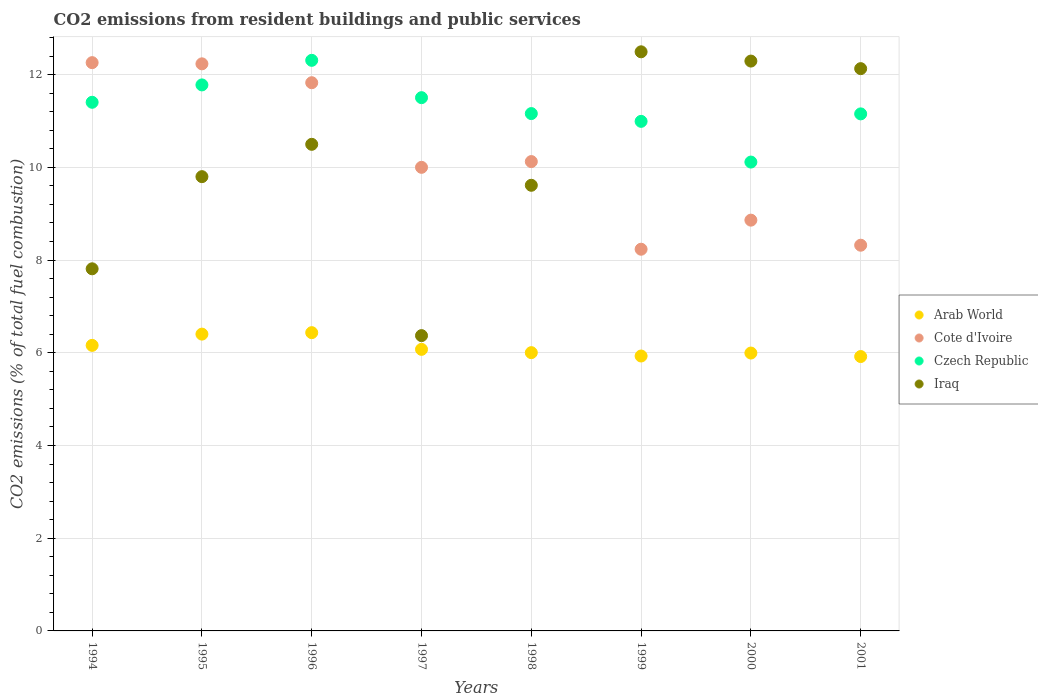Is the number of dotlines equal to the number of legend labels?
Give a very brief answer. Yes. What is the total CO2 emitted in Iraq in 1994?
Offer a very short reply. 7.81. Across all years, what is the maximum total CO2 emitted in Cote d'Ivoire?
Your answer should be very brief. 12.26. Across all years, what is the minimum total CO2 emitted in Iraq?
Your response must be concise. 6.37. In which year was the total CO2 emitted in Arab World maximum?
Ensure brevity in your answer.  1996. In which year was the total CO2 emitted in Iraq minimum?
Your response must be concise. 1997. What is the total total CO2 emitted in Iraq in the graph?
Provide a short and direct response. 81. What is the difference between the total CO2 emitted in Czech Republic in 1995 and that in 2001?
Your answer should be very brief. 0.62. What is the difference between the total CO2 emitted in Czech Republic in 1998 and the total CO2 emitted in Cote d'Ivoire in 1999?
Give a very brief answer. 2.93. What is the average total CO2 emitted in Iraq per year?
Ensure brevity in your answer.  10.13. In the year 1994, what is the difference between the total CO2 emitted in Arab World and total CO2 emitted in Iraq?
Offer a very short reply. -1.65. In how many years, is the total CO2 emitted in Cote d'Ivoire greater than 10.8?
Keep it short and to the point. 3. What is the ratio of the total CO2 emitted in Czech Republic in 1994 to that in 1996?
Offer a very short reply. 0.93. Is the total CO2 emitted in Arab World in 1996 less than that in 1997?
Offer a terse response. No. What is the difference between the highest and the second highest total CO2 emitted in Iraq?
Offer a very short reply. 0.2. What is the difference between the highest and the lowest total CO2 emitted in Czech Republic?
Give a very brief answer. 2.19. Is the sum of the total CO2 emitted in Cote d'Ivoire in 1996 and 2001 greater than the maximum total CO2 emitted in Czech Republic across all years?
Offer a very short reply. Yes. Is it the case that in every year, the sum of the total CO2 emitted in Cote d'Ivoire and total CO2 emitted in Iraq  is greater than the sum of total CO2 emitted in Arab World and total CO2 emitted in Czech Republic?
Offer a terse response. No. Is it the case that in every year, the sum of the total CO2 emitted in Arab World and total CO2 emitted in Iraq  is greater than the total CO2 emitted in Czech Republic?
Your answer should be very brief. Yes. How many dotlines are there?
Offer a terse response. 4. How many years are there in the graph?
Keep it short and to the point. 8. What is the difference between two consecutive major ticks on the Y-axis?
Your response must be concise. 2. Does the graph contain grids?
Your response must be concise. Yes. How many legend labels are there?
Make the answer very short. 4. What is the title of the graph?
Provide a short and direct response. CO2 emissions from resident buildings and public services. What is the label or title of the Y-axis?
Make the answer very short. CO2 emissions (% of total fuel combustion). What is the CO2 emissions (% of total fuel combustion) in Arab World in 1994?
Your answer should be compact. 6.16. What is the CO2 emissions (% of total fuel combustion) of Cote d'Ivoire in 1994?
Make the answer very short. 12.26. What is the CO2 emissions (% of total fuel combustion) in Czech Republic in 1994?
Ensure brevity in your answer.  11.4. What is the CO2 emissions (% of total fuel combustion) in Iraq in 1994?
Make the answer very short. 7.81. What is the CO2 emissions (% of total fuel combustion) of Arab World in 1995?
Offer a terse response. 6.4. What is the CO2 emissions (% of total fuel combustion) of Cote d'Ivoire in 1995?
Your answer should be compact. 12.23. What is the CO2 emissions (% of total fuel combustion) of Czech Republic in 1995?
Make the answer very short. 11.78. What is the CO2 emissions (% of total fuel combustion) of Iraq in 1995?
Offer a terse response. 9.8. What is the CO2 emissions (% of total fuel combustion) of Arab World in 1996?
Offer a very short reply. 6.43. What is the CO2 emissions (% of total fuel combustion) in Cote d'Ivoire in 1996?
Offer a terse response. 11.83. What is the CO2 emissions (% of total fuel combustion) in Czech Republic in 1996?
Provide a succinct answer. 12.31. What is the CO2 emissions (% of total fuel combustion) of Iraq in 1996?
Ensure brevity in your answer.  10.5. What is the CO2 emissions (% of total fuel combustion) of Arab World in 1997?
Ensure brevity in your answer.  6.07. What is the CO2 emissions (% of total fuel combustion) in Czech Republic in 1997?
Your answer should be compact. 11.5. What is the CO2 emissions (% of total fuel combustion) in Iraq in 1997?
Give a very brief answer. 6.37. What is the CO2 emissions (% of total fuel combustion) of Arab World in 1998?
Your answer should be compact. 6. What is the CO2 emissions (% of total fuel combustion) of Cote d'Ivoire in 1998?
Ensure brevity in your answer.  10.12. What is the CO2 emissions (% of total fuel combustion) of Czech Republic in 1998?
Keep it short and to the point. 11.16. What is the CO2 emissions (% of total fuel combustion) in Iraq in 1998?
Offer a very short reply. 9.61. What is the CO2 emissions (% of total fuel combustion) in Arab World in 1999?
Your answer should be compact. 5.93. What is the CO2 emissions (% of total fuel combustion) of Cote d'Ivoire in 1999?
Your answer should be compact. 8.23. What is the CO2 emissions (% of total fuel combustion) in Czech Republic in 1999?
Offer a terse response. 10.99. What is the CO2 emissions (% of total fuel combustion) in Iraq in 1999?
Keep it short and to the point. 12.49. What is the CO2 emissions (% of total fuel combustion) in Arab World in 2000?
Provide a succinct answer. 5.99. What is the CO2 emissions (% of total fuel combustion) in Cote d'Ivoire in 2000?
Provide a succinct answer. 8.86. What is the CO2 emissions (% of total fuel combustion) of Czech Republic in 2000?
Your answer should be compact. 10.11. What is the CO2 emissions (% of total fuel combustion) of Iraq in 2000?
Keep it short and to the point. 12.29. What is the CO2 emissions (% of total fuel combustion) of Arab World in 2001?
Offer a terse response. 5.92. What is the CO2 emissions (% of total fuel combustion) of Cote d'Ivoire in 2001?
Your response must be concise. 8.32. What is the CO2 emissions (% of total fuel combustion) of Czech Republic in 2001?
Provide a short and direct response. 11.15. What is the CO2 emissions (% of total fuel combustion) in Iraq in 2001?
Your answer should be compact. 12.13. Across all years, what is the maximum CO2 emissions (% of total fuel combustion) in Arab World?
Offer a very short reply. 6.43. Across all years, what is the maximum CO2 emissions (% of total fuel combustion) in Cote d'Ivoire?
Your answer should be very brief. 12.26. Across all years, what is the maximum CO2 emissions (% of total fuel combustion) in Czech Republic?
Your answer should be very brief. 12.31. Across all years, what is the maximum CO2 emissions (% of total fuel combustion) of Iraq?
Your response must be concise. 12.49. Across all years, what is the minimum CO2 emissions (% of total fuel combustion) in Arab World?
Provide a short and direct response. 5.92. Across all years, what is the minimum CO2 emissions (% of total fuel combustion) of Cote d'Ivoire?
Make the answer very short. 8.23. Across all years, what is the minimum CO2 emissions (% of total fuel combustion) in Czech Republic?
Ensure brevity in your answer.  10.11. Across all years, what is the minimum CO2 emissions (% of total fuel combustion) of Iraq?
Provide a succinct answer. 6.37. What is the total CO2 emissions (% of total fuel combustion) of Arab World in the graph?
Your answer should be very brief. 48.91. What is the total CO2 emissions (% of total fuel combustion) in Cote d'Ivoire in the graph?
Ensure brevity in your answer.  81.85. What is the total CO2 emissions (% of total fuel combustion) of Czech Republic in the graph?
Provide a succinct answer. 90.41. What is the total CO2 emissions (% of total fuel combustion) in Iraq in the graph?
Provide a short and direct response. 81. What is the difference between the CO2 emissions (% of total fuel combustion) in Arab World in 1994 and that in 1995?
Your response must be concise. -0.24. What is the difference between the CO2 emissions (% of total fuel combustion) in Cote d'Ivoire in 1994 and that in 1995?
Offer a terse response. 0.03. What is the difference between the CO2 emissions (% of total fuel combustion) in Czech Republic in 1994 and that in 1995?
Your answer should be compact. -0.37. What is the difference between the CO2 emissions (% of total fuel combustion) in Iraq in 1994 and that in 1995?
Provide a succinct answer. -1.99. What is the difference between the CO2 emissions (% of total fuel combustion) in Arab World in 1994 and that in 1996?
Provide a succinct answer. -0.27. What is the difference between the CO2 emissions (% of total fuel combustion) of Cote d'Ivoire in 1994 and that in 1996?
Your response must be concise. 0.43. What is the difference between the CO2 emissions (% of total fuel combustion) in Czech Republic in 1994 and that in 1996?
Offer a very short reply. -0.9. What is the difference between the CO2 emissions (% of total fuel combustion) in Iraq in 1994 and that in 1996?
Ensure brevity in your answer.  -2.69. What is the difference between the CO2 emissions (% of total fuel combustion) in Arab World in 1994 and that in 1997?
Your answer should be very brief. 0.09. What is the difference between the CO2 emissions (% of total fuel combustion) in Cote d'Ivoire in 1994 and that in 1997?
Provide a succinct answer. 2.26. What is the difference between the CO2 emissions (% of total fuel combustion) of Czech Republic in 1994 and that in 1997?
Ensure brevity in your answer.  -0.1. What is the difference between the CO2 emissions (% of total fuel combustion) in Iraq in 1994 and that in 1997?
Provide a succinct answer. 1.44. What is the difference between the CO2 emissions (% of total fuel combustion) of Arab World in 1994 and that in 1998?
Your response must be concise. 0.16. What is the difference between the CO2 emissions (% of total fuel combustion) in Cote d'Ivoire in 1994 and that in 1998?
Offer a terse response. 2.13. What is the difference between the CO2 emissions (% of total fuel combustion) in Czech Republic in 1994 and that in 1998?
Your answer should be compact. 0.24. What is the difference between the CO2 emissions (% of total fuel combustion) of Iraq in 1994 and that in 1998?
Make the answer very short. -1.8. What is the difference between the CO2 emissions (% of total fuel combustion) of Arab World in 1994 and that in 1999?
Offer a very short reply. 0.23. What is the difference between the CO2 emissions (% of total fuel combustion) of Cote d'Ivoire in 1994 and that in 1999?
Offer a terse response. 4.02. What is the difference between the CO2 emissions (% of total fuel combustion) in Czech Republic in 1994 and that in 1999?
Keep it short and to the point. 0.41. What is the difference between the CO2 emissions (% of total fuel combustion) in Iraq in 1994 and that in 1999?
Your answer should be very brief. -4.68. What is the difference between the CO2 emissions (% of total fuel combustion) in Arab World in 1994 and that in 2000?
Keep it short and to the point. 0.17. What is the difference between the CO2 emissions (% of total fuel combustion) in Cote d'Ivoire in 1994 and that in 2000?
Your answer should be very brief. 3.4. What is the difference between the CO2 emissions (% of total fuel combustion) of Czech Republic in 1994 and that in 2000?
Keep it short and to the point. 1.29. What is the difference between the CO2 emissions (% of total fuel combustion) in Iraq in 1994 and that in 2000?
Make the answer very short. -4.48. What is the difference between the CO2 emissions (% of total fuel combustion) in Arab World in 1994 and that in 2001?
Provide a short and direct response. 0.24. What is the difference between the CO2 emissions (% of total fuel combustion) in Cote d'Ivoire in 1994 and that in 2001?
Ensure brevity in your answer.  3.94. What is the difference between the CO2 emissions (% of total fuel combustion) of Czech Republic in 1994 and that in 2001?
Your answer should be compact. 0.25. What is the difference between the CO2 emissions (% of total fuel combustion) in Iraq in 1994 and that in 2001?
Your answer should be compact. -4.32. What is the difference between the CO2 emissions (% of total fuel combustion) in Arab World in 1995 and that in 1996?
Provide a succinct answer. -0.03. What is the difference between the CO2 emissions (% of total fuel combustion) in Cote d'Ivoire in 1995 and that in 1996?
Your response must be concise. 0.41. What is the difference between the CO2 emissions (% of total fuel combustion) in Czech Republic in 1995 and that in 1996?
Keep it short and to the point. -0.53. What is the difference between the CO2 emissions (% of total fuel combustion) of Iraq in 1995 and that in 1996?
Make the answer very short. -0.7. What is the difference between the CO2 emissions (% of total fuel combustion) in Arab World in 1995 and that in 1997?
Your response must be concise. 0.33. What is the difference between the CO2 emissions (% of total fuel combustion) of Cote d'Ivoire in 1995 and that in 1997?
Your answer should be compact. 2.23. What is the difference between the CO2 emissions (% of total fuel combustion) of Czech Republic in 1995 and that in 1997?
Make the answer very short. 0.28. What is the difference between the CO2 emissions (% of total fuel combustion) in Iraq in 1995 and that in 1997?
Your response must be concise. 3.43. What is the difference between the CO2 emissions (% of total fuel combustion) of Arab World in 1995 and that in 1998?
Offer a terse response. 0.4. What is the difference between the CO2 emissions (% of total fuel combustion) of Cote d'Ivoire in 1995 and that in 1998?
Give a very brief answer. 2.11. What is the difference between the CO2 emissions (% of total fuel combustion) in Czech Republic in 1995 and that in 1998?
Keep it short and to the point. 0.62. What is the difference between the CO2 emissions (% of total fuel combustion) of Iraq in 1995 and that in 1998?
Keep it short and to the point. 0.19. What is the difference between the CO2 emissions (% of total fuel combustion) in Arab World in 1995 and that in 1999?
Make the answer very short. 0.47. What is the difference between the CO2 emissions (% of total fuel combustion) of Cote d'Ivoire in 1995 and that in 1999?
Ensure brevity in your answer.  4. What is the difference between the CO2 emissions (% of total fuel combustion) of Czech Republic in 1995 and that in 1999?
Offer a very short reply. 0.79. What is the difference between the CO2 emissions (% of total fuel combustion) of Iraq in 1995 and that in 1999?
Make the answer very short. -2.69. What is the difference between the CO2 emissions (% of total fuel combustion) in Arab World in 1995 and that in 2000?
Make the answer very short. 0.41. What is the difference between the CO2 emissions (% of total fuel combustion) of Cote d'Ivoire in 1995 and that in 2000?
Give a very brief answer. 3.37. What is the difference between the CO2 emissions (% of total fuel combustion) in Czech Republic in 1995 and that in 2000?
Provide a short and direct response. 1.66. What is the difference between the CO2 emissions (% of total fuel combustion) of Iraq in 1995 and that in 2000?
Provide a short and direct response. -2.49. What is the difference between the CO2 emissions (% of total fuel combustion) of Arab World in 1995 and that in 2001?
Your answer should be compact. 0.48. What is the difference between the CO2 emissions (% of total fuel combustion) in Cote d'Ivoire in 1995 and that in 2001?
Your answer should be very brief. 3.91. What is the difference between the CO2 emissions (% of total fuel combustion) of Czech Republic in 1995 and that in 2001?
Ensure brevity in your answer.  0.62. What is the difference between the CO2 emissions (% of total fuel combustion) in Iraq in 1995 and that in 2001?
Offer a very short reply. -2.33. What is the difference between the CO2 emissions (% of total fuel combustion) in Arab World in 1996 and that in 1997?
Keep it short and to the point. 0.36. What is the difference between the CO2 emissions (% of total fuel combustion) in Cote d'Ivoire in 1996 and that in 1997?
Provide a succinct answer. 1.83. What is the difference between the CO2 emissions (% of total fuel combustion) of Czech Republic in 1996 and that in 1997?
Provide a succinct answer. 0.81. What is the difference between the CO2 emissions (% of total fuel combustion) in Iraq in 1996 and that in 1997?
Your answer should be very brief. 4.13. What is the difference between the CO2 emissions (% of total fuel combustion) of Arab World in 1996 and that in 1998?
Your response must be concise. 0.43. What is the difference between the CO2 emissions (% of total fuel combustion) in Cote d'Ivoire in 1996 and that in 1998?
Offer a very short reply. 1.7. What is the difference between the CO2 emissions (% of total fuel combustion) in Czech Republic in 1996 and that in 1998?
Your response must be concise. 1.15. What is the difference between the CO2 emissions (% of total fuel combustion) in Iraq in 1996 and that in 1998?
Your response must be concise. 0.88. What is the difference between the CO2 emissions (% of total fuel combustion) in Arab World in 1996 and that in 1999?
Ensure brevity in your answer.  0.5. What is the difference between the CO2 emissions (% of total fuel combustion) of Cote d'Ivoire in 1996 and that in 1999?
Your answer should be very brief. 3.59. What is the difference between the CO2 emissions (% of total fuel combustion) in Czech Republic in 1996 and that in 1999?
Your response must be concise. 1.32. What is the difference between the CO2 emissions (% of total fuel combustion) of Iraq in 1996 and that in 1999?
Your answer should be very brief. -2. What is the difference between the CO2 emissions (% of total fuel combustion) in Arab World in 1996 and that in 2000?
Provide a short and direct response. 0.44. What is the difference between the CO2 emissions (% of total fuel combustion) of Cote d'Ivoire in 1996 and that in 2000?
Your answer should be compact. 2.96. What is the difference between the CO2 emissions (% of total fuel combustion) of Czech Republic in 1996 and that in 2000?
Ensure brevity in your answer.  2.19. What is the difference between the CO2 emissions (% of total fuel combustion) in Iraq in 1996 and that in 2000?
Make the answer very short. -1.8. What is the difference between the CO2 emissions (% of total fuel combustion) of Arab World in 1996 and that in 2001?
Your answer should be very brief. 0.52. What is the difference between the CO2 emissions (% of total fuel combustion) of Cote d'Ivoire in 1996 and that in 2001?
Ensure brevity in your answer.  3.51. What is the difference between the CO2 emissions (% of total fuel combustion) of Czech Republic in 1996 and that in 2001?
Ensure brevity in your answer.  1.16. What is the difference between the CO2 emissions (% of total fuel combustion) of Iraq in 1996 and that in 2001?
Provide a succinct answer. -1.63. What is the difference between the CO2 emissions (% of total fuel combustion) of Arab World in 1997 and that in 1998?
Your response must be concise. 0.07. What is the difference between the CO2 emissions (% of total fuel combustion) in Cote d'Ivoire in 1997 and that in 1998?
Offer a terse response. -0.12. What is the difference between the CO2 emissions (% of total fuel combustion) of Czech Republic in 1997 and that in 1998?
Offer a very short reply. 0.34. What is the difference between the CO2 emissions (% of total fuel combustion) in Iraq in 1997 and that in 1998?
Keep it short and to the point. -3.24. What is the difference between the CO2 emissions (% of total fuel combustion) of Arab World in 1997 and that in 1999?
Give a very brief answer. 0.14. What is the difference between the CO2 emissions (% of total fuel combustion) of Cote d'Ivoire in 1997 and that in 1999?
Give a very brief answer. 1.77. What is the difference between the CO2 emissions (% of total fuel combustion) in Czech Republic in 1997 and that in 1999?
Your answer should be very brief. 0.51. What is the difference between the CO2 emissions (% of total fuel combustion) of Iraq in 1997 and that in 1999?
Your answer should be very brief. -6.12. What is the difference between the CO2 emissions (% of total fuel combustion) in Arab World in 1997 and that in 2000?
Your answer should be very brief. 0.08. What is the difference between the CO2 emissions (% of total fuel combustion) of Cote d'Ivoire in 1997 and that in 2000?
Your answer should be compact. 1.14. What is the difference between the CO2 emissions (% of total fuel combustion) in Czech Republic in 1997 and that in 2000?
Keep it short and to the point. 1.39. What is the difference between the CO2 emissions (% of total fuel combustion) of Iraq in 1997 and that in 2000?
Provide a succinct answer. -5.92. What is the difference between the CO2 emissions (% of total fuel combustion) of Arab World in 1997 and that in 2001?
Your answer should be very brief. 0.15. What is the difference between the CO2 emissions (% of total fuel combustion) of Cote d'Ivoire in 1997 and that in 2001?
Give a very brief answer. 1.68. What is the difference between the CO2 emissions (% of total fuel combustion) in Czech Republic in 1997 and that in 2001?
Make the answer very short. 0.35. What is the difference between the CO2 emissions (% of total fuel combustion) of Iraq in 1997 and that in 2001?
Provide a short and direct response. -5.76. What is the difference between the CO2 emissions (% of total fuel combustion) in Arab World in 1998 and that in 1999?
Your answer should be very brief. 0.07. What is the difference between the CO2 emissions (% of total fuel combustion) of Cote d'Ivoire in 1998 and that in 1999?
Make the answer very short. 1.89. What is the difference between the CO2 emissions (% of total fuel combustion) in Czech Republic in 1998 and that in 1999?
Give a very brief answer. 0.17. What is the difference between the CO2 emissions (% of total fuel combustion) in Iraq in 1998 and that in 1999?
Provide a short and direct response. -2.88. What is the difference between the CO2 emissions (% of total fuel combustion) of Arab World in 1998 and that in 2000?
Make the answer very short. 0.01. What is the difference between the CO2 emissions (% of total fuel combustion) in Cote d'Ivoire in 1998 and that in 2000?
Your answer should be compact. 1.26. What is the difference between the CO2 emissions (% of total fuel combustion) in Czech Republic in 1998 and that in 2000?
Offer a very short reply. 1.05. What is the difference between the CO2 emissions (% of total fuel combustion) of Iraq in 1998 and that in 2000?
Your answer should be very brief. -2.68. What is the difference between the CO2 emissions (% of total fuel combustion) of Arab World in 1998 and that in 2001?
Provide a succinct answer. 0.08. What is the difference between the CO2 emissions (% of total fuel combustion) of Cote d'Ivoire in 1998 and that in 2001?
Your answer should be very brief. 1.8. What is the difference between the CO2 emissions (% of total fuel combustion) of Czech Republic in 1998 and that in 2001?
Provide a short and direct response. 0.01. What is the difference between the CO2 emissions (% of total fuel combustion) in Iraq in 1998 and that in 2001?
Keep it short and to the point. -2.52. What is the difference between the CO2 emissions (% of total fuel combustion) in Arab World in 1999 and that in 2000?
Your response must be concise. -0.06. What is the difference between the CO2 emissions (% of total fuel combustion) of Cote d'Ivoire in 1999 and that in 2000?
Offer a terse response. -0.63. What is the difference between the CO2 emissions (% of total fuel combustion) in Czech Republic in 1999 and that in 2000?
Offer a very short reply. 0.88. What is the difference between the CO2 emissions (% of total fuel combustion) in Iraq in 1999 and that in 2000?
Your response must be concise. 0.2. What is the difference between the CO2 emissions (% of total fuel combustion) of Arab World in 1999 and that in 2001?
Ensure brevity in your answer.  0.01. What is the difference between the CO2 emissions (% of total fuel combustion) in Cote d'Ivoire in 1999 and that in 2001?
Give a very brief answer. -0.09. What is the difference between the CO2 emissions (% of total fuel combustion) in Czech Republic in 1999 and that in 2001?
Keep it short and to the point. -0.16. What is the difference between the CO2 emissions (% of total fuel combustion) in Iraq in 1999 and that in 2001?
Keep it short and to the point. 0.36. What is the difference between the CO2 emissions (% of total fuel combustion) in Arab World in 2000 and that in 2001?
Offer a terse response. 0.08. What is the difference between the CO2 emissions (% of total fuel combustion) of Cote d'Ivoire in 2000 and that in 2001?
Provide a succinct answer. 0.54. What is the difference between the CO2 emissions (% of total fuel combustion) in Czech Republic in 2000 and that in 2001?
Offer a very short reply. -1.04. What is the difference between the CO2 emissions (% of total fuel combustion) in Iraq in 2000 and that in 2001?
Provide a succinct answer. 0.16. What is the difference between the CO2 emissions (% of total fuel combustion) of Arab World in 1994 and the CO2 emissions (% of total fuel combustion) of Cote d'Ivoire in 1995?
Ensure brevity in your answer.  -6.07. What is the difference between the CO2 emissions (% of total fuel combustion) in Arab World in 1994 and the CO2 emissions (% of total fuel combustion) in Czech Republic in 1995?
Offer a very short reply. -5.62. What is the difference between the CO2 emissions (% of total fuel combustion) in Arab World in 1994 and the CO2 emissions (% of total fuel combustion) in Iraq in 1995?
Your response must be concise. -3.64. What is the difference between the CO2 emissions (% of total fuel combustion) of Cote d'Ivoire in 1994 and the CO2 emissions (% of total fuel combustion) of Czech Republic in 1995?
Ensure brevity in your answer.  0.48. What is the difference between the CO2 emissions (% of total fuel combustion) in Cote d'Ivoire in 1994 and the CO2 emissions (% of total fuel combustion) in Iraq in 1995?
Your response must be concise. 2.46. What is the difference between the CO2 emissions (% of total fuel combustion) in Czech Republic in 1994 and the CO2 emissions (% of total fuel combustion) in Iraq in 1995?
Provide a short and direct response. 1.6. What is the difference between the CO2 emissions (% of total fuel combustion) in Arab World in 1994 and the CO2 emissions (% of total fuel combustion) in Cote d'Ivoire in 1996?
Your answer should be very brief. -5.67. What is the difference between the CO2 emissions (% of total fuel combustion) of Arab World in 1994 and the CO2 emissions (% of total fuel combustion) of Czech Republic in 1996?
Keep it short and to the point. -6.15. What is the difference between the CO2 emissions (% of total fuel combustion) of Arab World in 1994 and the CO2 emissions (% of total fuel combustion) of Iraq in 1996?
Your answer should be very brief. -4.34. What is the difference between the CO2 emissions (% of total fuel combustion) in Cote d'Ivoire in 1994 and the CO2 emissions (% of total fuel combustion) in Czech Republic in 1996?
Offer a very short reply. -0.05. What is the difference between the CO2 emissions (% of total fuel combustion) in Cote d'Ivoire in 1994 and the CO2 emissions (% of total fuel combustion) in Iraq in 1996?
Provide a succinct answer. 1.76. What is the difference between the CO2 emissions (% of total fuel combustion) of Czech Republic in 1994 and the CO2 emissions (% of total fuel combustion) of Iraq in 1996?
Ensure brevity in your answer.  0.91. What is the difference between the CO2 emissions (% of total fuel combustion) of Arab World in 1994 and the CO2 emissions (% of total fuel combustion) of Cote d'Ivoire in 1997?
Offer a terse response. -3.84. What is the difference between the CO2 emissions (% of total fuel combustion) of Arab World in 1994 and the CO2 emissions (% of total fuel combustion) of Czech Republic in 1997?
Offer a terse response. -5.34. What is the difference between the CO2 emissions (% of total fuel combustion) in Arab World in 1994 and the CO2 emissions (% of total fuel combustion) in Iraq in 1997?
Provide a succinct answer. -0.21. What is the difference between the CO2 emissions (% of total fuel combustion) of Cote d'Ivoire in 1994 and the CO2 emissions (% of total fuel combustion) of Czech Republic in 1997?
Keep it short and to the point. 0.76. What is the difference between the CO2 emissions (% of total fuel combustion) in Cote d'Ivoire in 1994 and the CO2 emissions (% of total fuel combustion) in Iraq in 1997?
Provide a succinct answer. 5.89. What is the difference between the CO2 emissions (% of total fuel combustion) in Czech Republic in 1994 and the CO2 emissions (% of total fuel combustion) in Iraq in 1997?
Ensure brevity in your answer.  5.03. What is the difference between the CO2 emissions (% of total fuel combustion) of Arab World in 1994 and the CO2 emissions (% of total fuel combustion) of Cote d'Ivoire in 1998?
Offer a terse response. -3.96. What is the difference between the CO2 emissions (% of total fuel combustion) in Arab World in 1994 and the CO2 emissions (% of total fuel combustion) in Czech Republic in 1998?
Provide a short and direct response. -5. What is the difference between the CO2 emissions (% of total fuel combustion) of Arab World in 1994 and the CO2 emissions (% of total fuel combustion) of Iraq in 1998?
Offer a very short reply. -3.45. What is the difference between the CO2 emissions (% of total fuel combustion) in Cote d'Ivoire in 1994 and the CO2 emissions (% of total fuel combustion) in Czech Republic in 1998?
Keep it short and to the point. 1.1. What is the difference between the CO2 emissions (% of total fuel combustion) of Cote d'Ivoire in 1994 and the CO2 emissions (% of total fuel combustion) of Iraq in 1998?
Ensure brevity in your answer.  2.65. What is the difference between the CO2 emissions (% of total fuel combustion) of Czech Republic in 1994 and the CO2 emissions (% of total fuel combustion) of Iraq in 1998?
Ensure brevity in your answer.  1.79. What is the difference between the CO2 emissions (% of total fuel combustion) in Arab World in 1994 and the CO2 emissions (% of total fuel combustion) in Cote d'Ivoire in 1999?
Your answer should be very brief. -2.07. What is the difference between the CO2 emissions (% of total fuel combustion) of Arab World in 1994 and the CO2 emissions (% of total fuel combustion) of Czech Republic in 1999?
Your response must be concise. -4.83. What is the difference between the CO2 emissions (% of total fuel combustion) in Arab World in 1994 and the CO2 emissions (% of total fuel combustion) in Iraq in 1999?
Provide a short and direct response. -6.33. What is the difference between the CO2 emissions (% of total fuel combustion) of Cote d'Ivoire in 1994 and the CO2 emissions (% of total fuel combustion) of Czech Republic in 1999?
Make the answer very short. 1.27. What is the difference between the CO2 emissions (% of total fuel combustion) in Cote d'Ivoire in 1994 and the CO2 emissions (% of total fuel combustion) in Iraq in 1999?
Provide a succinct answer. -0.23. What is the difference between the CO2 emissions (% of total fuel combustion) of Czech Republic in 1994 and the CO2 emissions (% of total fuel combustion) of Iraq in 1999?
Make the answer very short. -1.09. What is the difference between the CO2 emissions (% of total fuel combustion) in Arab World in 1994 and the CO2 emissions (% of total fuel combustion) in Cote d'Ivoire in 2000?
Make the answer very short. -2.7. What is the difference between the CO2 emissions (% of total fuel combustion) in Arab World in 1994 and the CO2 emissions (% of total fuel combustion) in Czech Republic in 2000?
Offer a terse response. -3.95. What is the difference between the CO2 emissions (% of total fuel combustion) in Arab World in 1994 and the CO2 emissions (% of total fuel combustion) in Iraq in 2000?
Ensure brevity in your answer.  -6.13. What is the difference between the CO2 emissions (% of total fuel combustion) in Cote d'Ivoire in 1994 and the CO2 emissions (% of total fuel combustion) in Czech Republic in 2000?
Offer a very short reply. 2.14. What is the difference between the CO2 emissions (% of total fuel combustion) of Cote d'Ivoire in 1994 and the CO2 emissions (% of total fuel combustion) of Iraq in 2000?
Give a very brief answer. -0.03. What is the difference between the CO2 emissions (% of total fuel combustion) of Czech Republic in 1994 and the CO2 emissions (% of total fuel combustion) of Iraq in 2000?
Offer a very short reply. -0.89. What is the difference between the CO2 emissions (% of total fuel combustion) in Arab World in 1994 and the CO2 emissions (% of total fuel combustion) in Cote d'Ivoire in 2001?
Offer a very short reply. -2.16. What is the difference between the CO2 emissions (% of total fuel combustion) in Arab World in 1994 and the CO2 emissions (% of total fuel combustion) in Czech Republic in 2001?
Offer a terse response. -4.99. What is the difference between the CO2 emissions (% of total fuel combustion) of Arab World in 1994 and the CO2 emissions (% of total fuel combustion) of Iraq in 2001?
Your answer should be very brief. -5.97. What is the difference between the CO2 emissions (% of total fuel combustion) of Cote d'Ivoire in 1994 and the CO2 emissions (% of total fuel combustion) of Czech Republic in 2001?
Ensure brevity in your answer.  1.11. What is the difference between the CO2 emissions (% of total fuel combustion) of Cote d'Ivoire in 1994 and the CO2 emissions (% of total fuel combustion) of Iraq in 2001?
Give a very brief answer. 0.13. What is the difference between the CO2 emissions (% of total fuel combustion) of Czech Republic in 1994 and the CO2 emissions (% of total fuel combustion) of Iraq in 2001?
Ensure brevity in your answer.  -0.73. What is the difference between the CO2 emissions (% of total fuel combustion) of Arab World in 1995 and the CO2 emissions (% of total fuel combustion) of Cote d'Ivoire in 1996?
Your response must be concise. -5.42. What is the difference between the CO2 emissions (% of total fuel combustion) of Arab World in 1995 and the CO2 emissions (% of total fuel combustion) of Czech Republic in 1996?
Offer a very short reply. -5.91. What is the difference between the CO2 emissions (% of total fuel combustion) of Arab World in 1995 and the CO2 emissions (% of total fuel combustion) of Iraq in 1996?
Keep it short and to the point. -4.09. What is the difference between the CO2 emissions (% of total fuel combustion) in Cote d'Ivoire in 1995 and the CO2 emissions (% of total fuel combustion) in Czech Republic in 1996?
Keep it short and to the point. -0.08. What is the difference between the CO2 emissions (% of total fuel combustion) of Cote d'Ivoire in 1995 and the CO2 emissions (% of total fuel combustion) of Iraq in 1996?
Make the answer very short. 1.74. What is the difference between the CO2 emissions (% of total fuel combustion) in Czech Republic in 1995 and the CO2 emissions (% of total fuel combustion) in Iraq in 1996?
Your answer should be very brief. 1.28. What is the difference between the CO2 emissions (% of total fuel combustion) in Arab World in 1995 and the CO2 emissions (% of total fuel combustion) in Cote d'Ivoire in 1997?
Offer a terse response. -3.6. What is the difference between the CO2 emissions (% of total fuel combustion) in Arab World in 1995 and the CO2 emissions (% of total fuel combustion) in Czech Republic in 1997?
Ensure brevity in your answer.  -5.1. What is the difference between the CO2 emissions (% of total fuel combustion) in Arab World in 1995 and the CO2 emissions (% of total fuel combustion) in Iraq in 1997?
Give a very brief answer. 0.03. What is the difference between the CO2 emissions (% of total fuel combustion) in Cote d'Ivoire in 1995 and the CO2 emissions (% of total fuel combustion) in Czech Republic in 1997?
Your answer should be compact. 0.73. What is the difference between the CO2 emissions (% of total fuel combustion) of Cote d'Ivoire in 1995 and the CO2 emissions (% of total fuel combustion) of Iraq in 1997?
Offer a terse response. 5.86. What is the difference between the CO2 emissions (% of total fuel combustion) in Czech Republic in 1995 and the CO2 emissions (% of total fuel combustion) in Iraq in 1997?
Offer a terse response. 5.41. What is the difference between the CO2 emissions (% of total fuel combustion) in Arab World in 1995 and the CO2 emissions (% of total fuel combustion) in Cote d'Ivoire in 1998?
Your answer should be very brief. -3.72. What is the difference between the CO2 emissions (% of total fuel combustion) of Arab World in 1995 and the CO2 emissions (% of total fuel combustion) of Czech Republic in 1998?
Provide a short and direct response. -4.76. What is the difference between the CO2 emissions (% of total fuel combustion) in Arab World in 1995 and the CO2 emissions (% of total fuel combustion) in Iraq in 1998?
Your answer should be compact. -3.21. What is the difference between the CO2 emissions (% of total fuel combustion) in Cote d'Ivoire in 1995 and the CO2 emissions (% of total fuel combustion) in Czech Republic in 1998?
Offer a very short reply. 1.07. What is the difference between the CO2 emissions (% of total fuel combustion) of Cote d'Ivoire in 1995 and the CO2 emissions (% of total fuel combustion) of Iraq in 1998?
Give a very brief answer. 2.62. What is the difference between the CO2 emissions (% of total fuel combustion) of Czech Republic in 1995 and the CO2 emissions (% of total fuel combustion) of Iraq in 1998?
Keep it short and to the point. 2.17. What is the difference between the CO2 emissions (% of total fuel combustion) of Arab World in 1995 and the CO2 emissions (% of total fuel combustion) of Cote d'Ivoire in 1999?
Offer a terse response. -1.83. What is the difference between the CO2 emissions (% of total fuel combustion) of Arab World in 1995 and the CO2 emissions (% of total fuel combustion) of Czech Republic in 1999?
Offer a terse response. -4.59. What is the difference between the CO2 emissions (% of total fuel combustion) of Arab World in 1995 and the CO2 emissions (% of total fuel combustion) of Iraq in 1999?
Provide a short and direct response. -6.09. What is the difference between the CO2 emissions (% of total fuel combustion) in Cote d'Ivoire in 1995 and the CO2 emissions (% of total fuel combustion) in Czech Republic in 1999?
Your answer should be compact. 1.24. What is the difference between the CO2 emissions (% of total fuel combustion) of Cote d'Ivoire in 1995 and the CO2 emissions (% of total fuel combustion) of Iraq in 1999?
Keep it short and to the point. -0.26. What is the difference between the CO2 emissions (% of total fuel combustion) of Czech Republic in 1995 and the CO2 emissions (% of total fuel combustion) of Iraq in 1999?
Your answer should be compact. -0.71. What is the difference between the CO2 emissions (% of total fuel combustion) in Arab World in 1995 and the CO2 emissions (% of total fuel combustion) in Cote d'Ivoire in 2000?
Offer a very short reply. -2.46. What is the difference between the CO2 emissions (% of total fuel combustion) in Arab World in 1995 and the CO2 emissions (% of total fuel combustion) in Czech Republic in 2000?
Keep it short and to the point. -3.71. What is the difference between the CO2 emissions (% of total fuel combustion) of Arab World in 1995 and the CO2 emissions (% of total fuel combustion) of Iraq in 2000?
Provide a short and direct response. -5.89. What is the difference between the CO2 emissions (% of total fuel combustion) in Cote d'Ivoire in 1995 and the CO2 emissions (% of total fuel combustion) in Czech Republic in 2000?
Give a very brief answer. 2.12. What is the difference between the CO2 emissions (% of total fuel combustion) of Cote d'Ivoire in 1995 and the CO2 emissions (% of total fuel combustion) of Iraq in 2000?
Keep it short and to the point. -0.06. What is the difference between the CO2 emissions (% of total fuel combustion) in Czech Republic in 1995 and the CO2 emissions (% of total fuel combustion) in Iraq in 2000?
Your response must be concise. -0.51. What is the difference between the CO2 emissions (% of total fuel combustion) in Arab World in 1995 and the CO2 emissions (% of total fuel combustion) in Cote d'Ivoire in 2001?
Your answer should be compact. -1.92. What is the difference between the CO2 emissions (% of total fuel combustion) of Arab World in 1995 and the CO2 emissions (% of total fuel combustion) of Czech Republic in 2001?
Offer a very short reply. -4.75. What is the difference between the CO2 emissions (% of total fuel combustion) of Arab World in 1995 and the CO2 emissions (% of total fuel combustion) of Iraq in 2001?
Make the answer very short. -5.73. What is the difference between the CO2 emissions (% of total fuel combustion) of Cote d'Ivoire in 1995 and the CO2 emissions (% of total fuel combustion) of Czech Republic in 2001?
Give a very brief answer. 1.08. What is the difference between the CO2 emissions (% of total fuel combustion) in Cote d'Ivoire in 1995 and the CO2 emissions (% of total fuel combustion) in Iraq in 2001?
Provide a succinct answer. 0.1. What is the difference between the CO2 emissions (% of total fuel combustion) of Czech Republic in 1995 and the CO2 emissions (% of total fuel combustion) of Iraq in 2001?
Your response must be concise. -0.35. What is the difference between the CO2 emissions (% of total fuel combustion) of Arab World in 1996 and the CO2 emissions (% of total fuel combustion) of Cote d'Ivoire in 1997?
Make the answer very short. -3.57. What is the difference between the CO2 emissions (% of total fuel combustion) in Arab World in 1996 and the CO2 emissions (% of total fuel combustion) in Czech Republic in 1997?
Provide a succinct answer. -5.07. What is the difference between the CO2 emissions (% of total fuel combustion) in Arab World in 1996 and the CO2 emissions (% of total fuel combustion) in Iraq in 1997?
Make the answer very short. 0.06. What is the difference between the CO2 emissions (% of total fuel combustion) of Cote d'Ivoire in 1996 and the CO2 emissions (% of total fuel combustion) of Czech Republic in 1997?
Ensure brevity in your answer.  0.32. What is the difference between the CO2 emissions (% of total fuel combustion) in Cote d'Ivoire in 1996 and the CO2 emissions (% of total fuel combustion) in Iraq in 1997?
Make the answer very short. 5.46. What is the difference between the CO2 emissions (% of total fuel combustion) in Czech Republic in 1996 and the CO2 emissions (% of total fuel combustion) in Iraq in 1997?
Offer a terse response. 5.94. What is the difference between the CO2 emissions (% of total fuel combustion) of Arab World in 1996 and the CO2 emissions (% of total fuel combustion) of Cote d'Ivoire in 1998?
Ensure brevity in your answer.  -3.69. What is the difference between the CO2 emissions (% of total fuel combustion) in Arab World in 1996 and the CO2 emissions (% of total fuel combustion) in Czech Republic in 1998?
Ensure brevity in your answer.  -4.73. What is the difference between the CO2 emissions (% of total fuel combustion) in Arab World in 1996 and the CO2 emissions (% of total fuel combustion) in Iraq in 1998?
Offer a terse response. -3.18. What is the difference between the CO2 emissions (% of total fuel combustion) of Cote d'Ivoire in 1996 and the CO2 emissions (% of total fuel combustion) of Czech Republic in 1998?
Provide a short and direct response. 0.67. What is the difference between the CO2 emissions (% of total fuel combustion) of Cote d'Ivoire in 1996 and the CO2 emissions (% of total fuel combustion) of Iraq in 1998?
Make the answer very short. 2.21. What is the difference between the CO2 emissions (% of total fuel combustion) in Czech Republic in 1996 and the CO2 emissions (% of total fuel combustion) in Iraq in 1998?
Offer a terse response. 2.7. What is the difference between the CO2 emissions (% of total fuel combustion) of Arab World in 1996 and the CO2 emissions (% of total fuel combustion) of Cote d'Ivoire in 1999?
Give a very brief answer. -1.8. What is the difference between the CO2 emissions (% of total fuel combustion) of Arab World in 1996 and the CO2 emissions (% of total fuel combustion) of Czech Republic in 1999?
Give a very brief answer. -4.56. What is the difference between the CO2 emissions (% of total fuel combustion) in Arab World in 1996 and the CO2 emissions (% of total fuel combustion) in Iraq in 1999?
Give a very brief answer. -6.06. What is the difference between the CO2 emissions (% of total fuel combustion) in Cote d'Ivoire in 1996 and the CO2 emissions (% of total fuel combustion) in Czech Republic in 1999?
Ensure brevity in your answer.  0.83. What is the difference between the CO2 emissions (% of total fuel combustion) of Cote d'Ivoire in 1996 and the CO2 emissions (% of total fuel combustion) of Iraq in 1999?
Give a very brief answer. -0.67. What is the difference between the CO2 emissions (% of total fuel combustion) of Czech Republic in 1996 and the CO2 emissions (% of total fuel combustion) of Iraq in 1999?
Provide a succinct answer. -0.18. What is the difference between the CO2 emissions (% of total fuel combustion) in Arab World in 1996 and the CO2 emissions (% of total fuel combustion) in Cote d'Ivoire in 2000?
Provide a succinct answer. -2.43. What is the difference between the CO2 emissions (% of total fuel combustion) in Arab World in 1996 and the CO2 emissions (% of total fuel combustion) in Czech Republic in 2000?
Provide a succinct answer. -3.68. What is the difference between the CO2 emissions (% of total fuel combustion) of Arab World in 1996 and the CO2 emissions (% of total fuel combustion) of Iraq in 2000?
Ensure brevity in your answer.  -5.86. What is the difference between the CO2 emissions (% of total fuel combustion) of Cote d'Ivoire in 1996 and the CO2 emissions (% of total fuel combustion) of Czech Republic in 2000?
Make the answer very short. 1.71. What is the difference between the CO2 emissions (% of total fuel combustion) in Cote d'Ivoire in 1996 and the CO2 emissions (% of total fuel combustion) in Iraq in 2000?
Provide a short and direct response. -0.47. What is the difference between the CO2 emissions (% of total fuel combustion) in Czech Republic in 1996 and the CO2 emissions (% of total fuel combustion) in Iraq in 2000?
Your answer should be very brief. 0.02. What is the difference between the CO2 emissions (% of total fuel combustion) of Arab World in 1996 and the CO2 emissions (% of total fuel combustion) of Cote d'Ivoire in 2001?
Your response must be concise. -1.89. What is the difference between the CO2 emissions (% of total fuel combustion) of Arab World in 1996 and the CO2 emissions (% of total fuel combustion) of Czech Republic in 2001?
Keep it short and to the point. -4.72. What is the difference between the CO2 emissions (% of total fuel combustion) in Arab World in 1996 and the CO2 emissions (% of total fuel combustion) in Iraq in 2001?
Offer a terse response. -5.69. What is the difference between the CO2 emissions (% of total fuel combustion) in Cote d'Ivoire in 1996 and the CO2 emissions (% of total fuel combustion) in Czech Republic in 2001?
Your response must be concise. 0.67. What is the difference between the CO2 emissions (% of total fuel combustion) in Cote d'Ivoire in 1996 and the CO2 emissions (% of total fuel combustion) in Iraq in 2001?
Your response must be concise. -0.3. What is the difference between the CO2 emissions (% of total fuel combustion) in Czech Republic in 1996 and the CO2 emissions (% of total fuel combustion) in Iraq in 2001?
Offer a terse response. 0.18. What is the difference between the CO2 emissions (% of total fuel combustion) of Arab World in 1997 and the CO2 emissions (% of total fuel combustion) of Cote d'Ivoire in 1998?
Give a very brief answer. -4.05. What is the difference between the CO2 emissions (% of total fuel combustion) in Arab World in 1997 and the CO2 emissions (% of total fuel combustion) in Czech Republic in 1998?
Your response must be concise. -5.09. What is the difference between the CO2 emissions (% of total fuel combustion) in Arab World in 1997 and the CO2 emissions (% of total fuel combustion) in Iraq in 1998?
Ensure brevity in your answer.  -3.54. What is the difference between the CO2 emissions (% of total fuel combustion) of Cote d'Ivoire in 1997 and the CO2 emissions (% of total fuel combustion) of Czech Republic in 1998?
Provide a succinct answer. -1.16. What is the difference between the CO2 emissions (% of total fuel combustion) in Cote d'Ivoire in 1997 and the CO2 emissions (% of total fuel combustion) in Iraq in 1998?
Give a very brief answer. 0.39. What is the difference between the CO2 emissions (% of total fuel combustion) of Czech Republic in 1997 and the CO2 emissions (% of total fuel combustion) of Iraq in 1998?
Provide a short and direct response. 1.89. What is the difference between the CO2 emissions (% of total fuel combustion) in Arab World in 1997 and the CO2 emissions (% of total fuel combustion) in Cote d'Ivoire in 1999?
Your answer should be compact. -2.16. What is the difference between the CO2 emissions (% of total fuel combustion) of Arab World in 1997 and the CO2 emissions (% of total fuel combustion) of Czech Republic in 1999?
Provide a succinct answer. -4.92. What is the difference between the CO2 emissions (% of total fuel combustion) in Arab World in 1997 and the CO2 emissions (% of total fuel combustion) in Iraq in 1999?
Offer a terse response. -6.42. What is the difference between the CO2 emissions (% of total fuel combustion) in Cote d'Ivoire in 1997 and the CO2 emissions (% of total fuel combustion) in Czech Republic in 1999?
Offer a very short reply. -0.99. What is the difference between the CO2 emissions (% of total fuel combustion) in Cote d'Ivoire in 1997 and the CO2 emissions (% of total fuel combustion) in Iraq in 1999?
Provide a succinct answer. -2.49. What is the difference between the CO2 emissions (% of total fuel combustion) in Czech Republic in 1997 and the CO2 emissions (% of total fuel combustion) in Iraq in 1999?
Keep it short and to the point. -0.99. What is the difference between the CO2 emissions (% of total fuel combustion) in Arab World in 1997 and the CO2 emissions (% of total fuel combustion) in Cote d'Ivoire in 2000?
Offer a terse response. -2.79. What is the difference between the CO2 emissions (% of total fuel combustion) of Arab World in 1997 and the CO2 emissions (% of total fuel combustion) of Czech Republic in 2000?
Give a very brief answer. -4.04. What is the difference between the CO2 emissions (% of total fuel combustion) of Arab World in 1997 and the CO2 emissions (% of total fuel combustion) of Iraq in 2000?
Offer a terse response. -6.22. What is the difference between the CO2 emissions (% of total fuel combustion) in Cote d'Ivoire in 1997 and the CO2 emissions (% of total fuel combustion) in Czech Republic in 2000?
Offer a terse response. -0.11. What is the difference between the CO2 emissions (% of total fuel combustion) in Cote d'Ivoire in 1997 and the CO2 emissions (% of total fuel combustion) in Iraq in 2000?
Provide a succinct answer. -2.29. What is the difference between the CO2 emissions (% of total fuel combustion) in Czech Republic in 1997 and the CO2 emissions (% of total fuel combustion) in Iraq in 2000?
Give a very brief answer. -0.79. What is the difference between the CO2 emissions (% of total fuel combustion) of Arab World in 1997 and the CO2 emissions (% of total fuel combustion) of Cote d'Ivoire in 2001?
Give a very brief answer. -2.25. What is the difference between the CO2 emissions (% of total fuel combustion) in Arab World in 1997 and the CO2 emissions (% of total fuel combustion) in Czech Republic in 2001?
Offer a very short reply. -5.08. What is the difference between the CO2 emissions (% of total fuel combustion) of Arab World in 1997 and the CO2 emissions (% of total fuel combustion) of Iraq in 2001?
Offer a very short reply. -6.05. What is the difference between the CO2 emissions (% of total fuel combustion) in Cote d'Ivoire in 1997 and the CO2 emissions (% of total fuel combustion) in Czech Republic in 2001?
Ensure brevity in your answer.  -1.15. What is the difference between the CO2 emissions (% of total fuel combustion) of Cote d'Ivoire in 1997 and the CO2 emissions (% of total fuel combustion) of Iraq in 2001?
Your answer should be very brief. -2.13. What is the difference between the CO2 emissions (% of total fuel combustion) in Czech Republic in 1997 and the CO2 emissions (% of total fuel combustion) in Iraq in 2001?
Offer a very short reply. -0.63. What is the difference between the CO2 emissions (% of total fuel combustion) of Arab World in 1998 and the CO2 emissions (% of total fuel combustion) of Cote d'Ivoire in 1999?
Your answer should be compact. -2.23. What is the difference between the CO2 emissions (% of total fuel combustion) of Arab World in 1998 and the CO2 emissions (% of total fuel combustion) of Czech Republic in 1999?
Keep it short and to the point. -4.99. What is the difference between the CO2 emissions (% of total fuel combustion) of Arab World in 1998 and the CO2 emissions (% of total fuel combustion) of Iraq in 1999?
Offer a very short reply. -6.49. What is the difference between the CO2 emissions (% of total fuel combustion) of Cote d'Ivoire in 1998 and the CO2 emissions (% of total fuel combustion) of Czech Republic in 1999?
Make the answer very short. -0.87. What is the difference between the CO2 emissions (% of total fuel combustion) in Cote d'Ivoire in 1998 and the CO2 emissions (% of total fuel combustion) in Iraq in 1999?
Your response must be concise. -2.37. What is the difference between the CO2 emissions (% of total fuel combustion) in Czech Republic in 1998 and the CO2 emissions (% of total fuel combustion) in Iraq in 1999?
Offer a terse response. -1.33. What is the difference between the CO2 emissions (% of total fuel combustion) of Arab World in 1998 and the CO2 emissions (% of total fuel combustion) of Cote d'Ivoire in 2000?
Your response must be concise. -2.86. What is the difference between the CO2 emissions (% of total fuel combustion) in Arab World in 1998 and the CO2 emissions (% of total fuel combustion) in Czech Republic in 2000?
Your answer should be very brief. -4.11. What is the difference between the CO2 emissions (% of total fuel combustion) in Arab World in 1998 and the CO2 emissions (% of total fuel combustion) in Iraq in 2000?
Offer a very short reply. -6.29. What is the difference between the CO2 emissions (% of total fuel combustion) of Cote d'Ivoire in 1998 and the CO2 emissions (% of total fuel combustion) of Czech Republic in 2000?
Give a very brief answer. 0.01. What is the difference between the CO2 emissions (% of total fuel combustion) of Cote d'Ivoire in 1998 and the CO2 emissions (% of total fuel combustion) of Iraq in 2000?
Offer a very short reply. -2.17. What is the difference between the CO2 emissions (% of total fuel combustion) of Czech Republic in 1998 and the CO2 emissions (% of total fuel combustion) of Iraq in 2000?
Make the answer very short. -1.13. What is the difference between the CO2 emissions (% of total fuel combustion) of Arab World in 1998 and the CO2 emissions (% of total fuel combustion) of Cote d'Ivoire in 2001?
Your answer should be very brief. -2.32. What is the difference between the CO2 emissions (% of total fuel combustion) of Arab World in 1998 and the CO2 emissions (% of total fuel combustion) of Czech Republic in 2001?
Your answer should be very brief. -5.15. What is the difference between the CO2 emissions (% of total fuel combustion) of Arab World in 1998 and the CO2 emissions (% of total fuel combustion) of Iraq in 2001?
Your answer should be compact. -6.13. What is the difference between the CO2 emissions (% of total fuel combustion) of Cote d'Ivoire in 1998 and the CO2 emissions (% of total fuel combustion) of Czech Republic in 2001?
Provide a succinct answer. -1.03. What is the difference between the CO2 emissions (% of total fuel combustion) of Cote d'Ivoire in 1998 and the CO2 emissions (% of total fuel combustion) of Iraq in 2001?
Keep it short and to the point. -2. What is the difference between the CO2 emissions (% of total fuel combustion) of Czech Republic in 1998 and the CO2 emissions (% of total fuel combustion) of Iraq in 2001?
Your response must be concise. -0.97. What is the difference between the CO2 emissions (% of total fuel combustion) in Arab World in 1999 and the CO2 emissions (% of total fuel combustion) in Cote d'Ivoire in 2000?
Provide a succinct answer. -2.93. What is the difference between the CO2 emissions (% of total fuel combustion) in Arab World in 1999 and the CO2 emissions (% of total fuel combustion) in Czech Republic in 2000?
Ensure brevity in your answer.  -4.18. What is the difference between the CO2 emissions (% of total fuel combustion) in Arab World in 1999 and the CO2 emissions (% of total fuel combustion) in Iraq in 2000?
Your response must be concise. -6.36. What is the difference between the CO2 emissions (% of total fuel combustion) in Cote d'Ivoire in 1999 and the CO2 emissions (% of total fuel combustion) in Czech Republic in 2000?
Make the answer very short. -1.88. What is the difference between the CO2 emissions (% of total fuel combustion) of Cote d'Ivoire in 1999 and the CO2 emissions (% of total fuel combustion) of Iraq in 2000?
Offer a terse response. -4.06. What is the difference between the CO2 emissions (% of total fuel combustion) of Czech Republic in 1999 and the CO2 emissions (% of total fuel combustion) of Iraq in 2000?
Your response must be concise. -1.3. What is the difference between the CO2 emissions (% of total fuel combustion) in Arab World in 1999 and the CO2 emissions (% of total fuel combustion) in Cote d'Ivoire in 2001?
Provide a succinct answer. -2.39. What is the difference between the CO2 emissions (% of total fuel combustion) in Arab World in 1999 and the CO2 emissions (% of total fuel combustion) in Czech Republic in 2001?
Give a very brief answer. -5.22. What is the difference between the CO2 emissions (% of total fuel combustion) in Arab World in 1999 and the CO2 emissions (% of total fuel combustion) in Iraq in 2001?
Offer a very short reply. -6.2. What is the difference between the CO2 emissions (% of total fuel combustion) in Cote d'Ivoire in 1999 and the CO2 emissions (% of total fuel combustion) in Czech Republic in 2001?
Make the answer very short. -2.92. What is the difference between the CO2 emissions (% of total fuel combustion) in Cote d'Ivoire in 1999 and the CO2 emissions (% of total fuel combustion) in Iraq in 2001?
Offer a terse response. -3.9. What is the difference between the CO2 emissions (% of total fuel combustion) of Czech Republic in 1999 and the CO2 emissions (% of total fuel combustion) of Iraq in 2001?
Provide a short and direct response. -1.14. What is the difference between the CO2 emissions (% of total fuel combustion) of Arab World in 2000 and the CO2 emissions (% of total fuel combustion) of Cote d'Ivoire in 2001?
Give a very brief answer. -2.33. What is the difference between the CO2 emissions (% of total fuel combustion) of Arab World in 2000 and the CO2 emissions (% of total fuel combustion) of Czech Republic in 2001?
Keep it short and to the point. -5.16. What is the difference between the CO2 emissions (% of total fuel combustion) in Arab World in 2000 and the CO2 emissions (% of total fuel combustion) in Iraq in 2001?
Your answer should be compact. -6.13. What is the difference between the CO2 emissions (% of total fuel combustion) of Cote d'Ivoire in 2000 and the CO2 emissions (% of total fuel combustion) of Czech Republic in 2001?
Make the answer very short. -2.29. What is the difference between the CO2 emissions (% of total fuel combustion) in Cote d'Ivoire in 2000 and the CO2 emissions (% of total fuel combustion) in Iraq in 2001?
Your answer should be compact. -3.27. What is the difference between the CO2 emissions (% of total fuel combustion) in Czech Republic in 2000 and the CO2 emissions (% of total fuel combustion) in Iraq in 2001?
Ensure brevity in your answer.  -2.02. What is the average CO2 emissions (% of total fuel combustion) in Arab World per year?
Make the answer very short. 6.11. What is the average CO2 emissions (% of total fuel combustion) in Cote d'Ivoire per year?
Ensure brevity in your answer.  10.23. What is the average CO2 emissions (% of total fuel combustion) in Czech Republic per year?
Provide a short and direct response. 11.3. What is the average CO2 emissions (% of total fuel combustion) of Iraq per year?
Give a very brief answer. 10.13. In the year 1994, what is the difference between the CO2 emissions (% of total fuel combustion) in Arab World and CO2 emissions (% of total fuel combustion) in Cote d'Ivoire?
Make the answer very short. -6.1. In the year 1994, what is the difference between the CO2 emissions (% of total fuel combustion) in Arab World and CO2 emissions (% of total fuel combustion) in Czech Republic?
Make the answer very short. -5.24. In the year 1994, what is the difference between the CO2 emissions (% of total fuel combustion) of Arab World and CO2 emissions (% of total fuel combustion) of Iraq?
Your answer should be very brief. -1.65. In the year 1994, what is the difference between the CO2 emissions (% of total fuel combustion) of Cote d'Ivoire and CO2 emissions (% of total fuel combustion) of Czech Republic?
Give a very brief answer. 0.85. In the year 1994, what is the difference between the CO2 emissions (% of total fuel combustion) of Cote d'Ivoire and CO2 emissions (% of total fuel combustion) of Iraq?
Ensure brevity in your answer.  4.45. In the year 1994, what is the difference between the CO2 emissions (% of total fuel combustion) of Czech Republic and CO2 emissions (% of total fuel combustion) of Iraq?
Your response must be concise. 3.59. In the year 1995, what is the difference between the CO2 emissions (% of total fuel combustion) of Arab World and CO2 emissions (% of total fuel combustion) of Cote d'Ivoire?
Your answer should be compact. -5.83. In the year 1995, what is the difference between the CO2 emissions (% of total fuel combustion) of Arab World and CO2 emissions (% of total fuel combustion) of Czech Republic?
Your answer should be compact. -5.38. In the year 1995, what is the difference between the CO2 emissions (% of total fuel combustion) in Arab World and CO2 emissions (% of total fuel combustion) in Iraq?
Your answer should be compact. -3.4. In the year 1995, what is the difference between the CO2 emissions (% of total fuel combustion) in Cote d'Ivoire and CO2 emissions (% of total fuel combustion) in Czech Republic?
Offer a very short reply. 0.45. In the year 1995, what is the difference between the CO2 emissions (% of total fuel combustion) of Cote d'Ivoire and CO2 emissions (% of total fuel combustion) of Iraq?
Offer a very short reply. 2.43. In the year 1995, what is the difference between the CO2 emissions (% of total fuel combustion) in Czech Republic and CO2 emissions (% of total fuel combustion) in Iraq?
Make the answer very short. 1.98. In the year 1996, what is the difference between the CO2 emissions (% of total fuel combustion) of Arab World and CO2 emissions (% of total fuel combustion) of Cote d'Ivoire?
Your answer should be very brief. -5.39. In the year 1996, what is the difference between the CO2 emissions (% of total fuel combustion) in Arab World and CO2 emissions (% of total fuel combustion) in Czech Republic?
Keep it short and to the point. -5.87. In the year 1996, what is the difference between the CO2 emissions (% of total fuel combustion) of Arab World and CO2 emissions (% of total fuel combustion) of Iraq?
Offer a very short reply. -4.06. In the year 1996, what is the difference between the CO2 emissions (% of total fuel combustion) in Cote d'Ivoire and CO2 emissions (% of total fuel combustion) in Czech Republic?
Offer a very short reply. -0.48. In the year 1996, what is the difference between the CO2 emissions (% of total fuel combustion) of Cote d'Ivoire and CO2 emissions (% of total fuel combustion) of Iraq?
Your answer should be compact. 1.33. In the year 1996, what is the difference between the CO2 emissions (% of total fuel combustion) of Czech Republic and CO2 emissions (% of total fuel combustion) of Iraq?
Your answer should be very brief. 1.81. In the year 1997, what is the difference between the CO2 emissions (% of total fuel combustion) of Arab World and CO2 emissions (% of total fuel combustion) of Cote d'Ivoire?
Offer a terse response. -3.93. In the year 1997, what is the difference between the CO2 emissions (% of total fuel combustion) of Arab World and CO2 emissions (% of total fuel combustion) of Czech Republic?
Give a very brief answer. -5.43. In the year 1997, what is the difference between the CO2 emissions (% of total fuel combustion) in Arab World and CO2 emissions (% of total fuel combustion) in Iraq?
Give a very brief answer. -0.3. In the year 1997, what is the difference between the CO2 emissions (% of total fuel combustion) in Cote d'Ivoire and CO2 emissions (% of total fuel combustion) in Czech Republic?
Provide a succinct answer. -1.5. In the year 1997, what is the difference between the CO2 emissions (% of total fuel combustion) in Cote d'Ivoire and CO2 emissions (% of total fuel combustion) in Iraq?
Make the answer very short. 3.63. In the year 1997, what is the difference between the CO2 emissions (% of total fuel combustion) in Czech Republic and CO2 emissions (% of total fuel combustion) in Iraq?
Make the answer very short. 5.13. In the year 1998, what is the difference between the CO2 emissions (% of total fuel combustion) in Arab World and CO2 emissions (% of total fuel combustion) in Cote d'Ivoire?
Your answer should be compact. -4.12. In the year 1998, what is the difference between the CO2 emissions (% of total fuel combustion) of Arab World and CO2 emissions (% of total fuel combustion) of Czech Republic?
Provide a succinct answer. -5.16. In the year 1998, what is the difference between the CO2 emissions (% of total fuel combustion) of Arab World and CO2 emissions (% of total fuel combustion) of Iraq?
Your answer should be compact. -3.61. In the year 1998, what is the difference between the CO2 emissions (% of total fuel combustion) of Cote d'Ivoire and CO2 emissions (% of total fuel combustion) of Czech Republic?
Your response must be concise. -1.04. In the year 1998, what is the difference between the CO2 emissions (% of total fuel combustion) of Cote d'Ivoire and CO2 emissions (% of total fuel combustion) of Iraq?
Your answer should be compact. 0.51. In the year 1998, what is the difference between the CO2 emissions (% of total fuel combustion) in Czech Republic and CO2 emissions (% of total fuel combustion) in Iraq?
Offer a very short reply. 1.55. In the year 1999, what is the difference between the CO2 emissions (% of total fuel combustion) in Arab World and CO2 emissions (% of total fuel combustion) in Cote d'Ivoire?
Ensure brevity in your answer.  -2.3. In the year 1999, what is the difference between the CO2 emissions (% of total fuel combustion) in Arab World and CO2 emissions (% of total fuel combustion) in Czech Republic?
Provide a succinct answer. -5.06. In the year 1999, what is the difference between the CO2 emissions (% of total fuel combustion) in Arab World and CO2 emissions (% of total fuel combustion) in Iraq?
Offer a very short reply. -6.56. In the year 1999, what is the difference between the CO2 emissions (% of total fuel combustion) of Cote d'Ivoire and CO2 emissions (% of total fuel combustion) of Czech Republic?
Your answer should be compact. -2.76. In the year 1999, what is the difference between the CO2 emissions (% of total fuel combustion) of Cote d'Ivoire and CO2 emissions (% of total fuel combustion) of Iraq?
Provide a short and direct response. -4.26. In the year 1999, what is the difference between the CO2 emissions (% of total fuel combustion) of Czech Republic and CO2 emissions (% of total fuel combustion) of Iraq?
Offer a very short reply. -1.5. In the year 2000, what is the difference between the CO2 emissions (% of total fuel combustion) in Arab World and CO2 emissions (% of total fuel combustion) in Cote d'Ivoire?
Provide a short and direct response. -2.87. In the year 2000, what is the difference between the CO2 emissions (% of total fuel combustion) in Arab World and CO2 emissions (% of total fuel combustion) in Czech Republic?
Provide a succinct answer. -4.12. In the year 2000, what is the difference between the CO2 emissions (% of total fuel combustion) of Arab World and CO2 emissions (% of total fuel combustion) of Iraq?
Provide a succinct answer. -6.3. In the year 2000, what is the difference between the CO2 emissions (% of total fuel combustion) in Cote d'Ivoire and CO2 emissions (% of total fuel combustion) in Czech Republic?
Your response must be concise. -1.25. In the year 2000, what is the difference between the CO2 emissions (% of total fuel combustion) of Cote d'Ivoire and CO2 emissions (% of total fuel combustion) of Iraq?
Make the answer very short. -3.43. In the year 2000, what is the difference between the CO2 emissions (% of total fuel combustion) of Czech Republic and CO2 emissions (% of total fuel combustion) of Iraq?
Provide a succinct answer. -2.18. In the year 2001, what is the difference between the CO2 emissions (% of total fuel combustion) of Arab World and CO2 emissions (% of total fuel combustion) of Cote d'Ivoire?
Your answer should be compact. -2.4. In the year 2001, what is the difference between the CO2 emissions (% of total fuel combustion) of Arab World and CO2 emissions (% of total fuel combustion) of Czech Republic?
Your response must be concise. -5.23. In the year 2001, what is the difference between the CO2 emissions (% of total fuel combustion) in Arab World and CO2 emissions (% of total fuel combustion) in Iraq?
Keep it short and to the point. -6.21. In the year 2001, what is the difference between the CO2 emissions (% of total fuel combustion) of Cote d'Ivoire and CO2 emissions (% of total fuel combustion) of Czech Republic?
Keep it short and to the point. -2.83. In the year 2001, what is the difference between the CO2 emissions (% of total fuel combustion) of Cote d'Ivoire and CO2 emissions (% of total fuel combustion) of Iraq?
Ensure brevity in your answer.  -3.81. In the year 2001, what is the difference between the CO2 emissions (% of total fuel combustion) of Czech Republic and CO2 emissions (% of total fuel combustion) of Iraq?
Your response must be concise. -0.98. What is the ratio of the CO2 emissions (% of total fuel combustion) in Arab World in 1994 to that in 1995?
Give a very brief answer. 0.96. What is the ratio of the CO2 emissions (% of total fuel combustion) of Cote d'Ivoire in 1994 to that in 1995?
Offer a very short reply. 1. What is the ratio of the CO2 emissions (% of total fuel combustion) in Czech Republic in 1994 to that in 1995?
Offer a very short reply. 0.97. What is the ratio of the CO2 emissions (% of total fuel combustion) in Iraq in 1994 to that in 1995?
Provide a succinct answer. 0.8. What is the ratio of the CO2 emissions (% of total fuel combustion) of Arab World in 1994 to that in 1996?
Provide a succinct answer. 0.96. What is the ratio of the CO2 emissions (% of total fuel combustion) in Cote d'Ivoire in 1994 to that in 1996?
Your answer should be very brief. 1.04. What is the ratio of the CO2 emissions (% of total fuel combustion) of Czech Republic in 1994 to that in 1996?
Offer a terse response. 0.93. What is the ratio of the CO2 emissions (% of total fuel combustion) in Iraq in 1994 to that in 1996?
Offer a terse response. 0.74. What is the ratio of the CO2 emissions (% of total fuel combustion) in Arab World in 1994 to that in 1997?
Keep it short and to the point. 1.01. What is the ratio of the CO2 emissions (% of total fuel combustion) in Cote d'Ivoire in 1994 to that in 1997?
Offer a very short reply. 1.23. What is the ratio of the CO2 emissions (% of total fuel combustion) in Iraq in 1994 to that in 1997?
Offer a terse response. 1.23. What is the ratio of the CO2 emissions (% of total fuel combustion) in Arab World in 1994 to that in 1998?
Provide a succinct answer. 1.03. What is the ratio of the CO2 emissions (% of total fuel combustion) of Cote d'Ivoire in 1994 to that in 1998?
Your answer should be very brief. 1.21. What is the ratio of the CO2 emissions (% of total fuel combustion) of Czech Republic in 1994 to that in 1998?
Your answer should be very brief. 1.02. What is the ratio of the CO2 emissions (% of total fuel combustion) of Iraq in 1994 to that in 1998?
Your answer should be very brief. 0.81. What is the ratio of the CO2 emissions (% of total fuel combustion) of Arab World in 1994 to that in 1999?
Offer a terse response. 1.04. What is the ratio of the CO2 emissions (% of total fuel combustion) in Cote d'Ivoire in 1994 to that in 1999?
Ensure brevity in your answer.  1.49. What is the ratio of the CO2 emissions (% of total fuel combustion) in Czech Republic in 1994 to that in 1999?
Make the answer very short. 1.04. What is the ratio of the CO2 emissions (% of total fuel combustion) in Iraq in 1994 to that in 1999?
Ensure brevity in your answer.  0.63. What is the ratio of the CO2 emissions (% of total fuel combustion) in Arab World in 1994 to that in 2000?
Give a very brief answer. 1.03. What is the ratio of the CO2 emissions (% of total fuel combustion) in Cote d'Ivoire in 1994 to that in 2000?
Offer a very short reply. 1.38. What is the ratio of the CO2 emissions (% of total fuel combustion) of Czech Republic in 1994 to that in 2000?
Provide a short and direct response. 1.13. What is the ratio of the CO2 emissions (% of total fuel combustion) of Iraq in 1994 to that in 2000?
Keep it short and to the point. 0.64. What is the ratio of the CO2 emissions (% of total fuel combustion) of Arab World in 1994 to that in 2001?
Keep it short and to the point. 1.04. What is the ratio of the CO2 emissions (% of total fuel combustion) in Cote d'Ivoire in 1994 to that in 2001?
Make the answer very short. 1.47. What is the ratio of the CO2 emissions (% of total fuel combustion) in Czech Republic in 1994 to that in 2001?
Your answer should be very brief. 1.02. What is the ratio of the CO2 emissions (% of total fuel combustion) of Iraq in 1994 to that in 2001?
Your answer should be compact. 0.64. What is the ratio of the CO2 emissions (% of total fuel combustion) of Arab World in 1995 to that in 1996?
Make the answer very short. 1. What is the ratio of the CO2 emissions (% of total fuel combustion) in Cote d'Ivoire in 1995 to that in 1996?
Offer a very short reply. 1.03. What is the ratio of the CO2 emissions (% of total fuel combustion) of Czech Republic in 1995 to that in 1996?
Ensure brevity in your answer.  0.96. What is the ratio of the CO2 emissions (% of total fuel combustion) in Iraq in 1995 to that in 1996?
Provide a short and direct response. 0.93. What is the ratio of the CO2 emissions (% of total fuel combustion) of Arab World in 1995 to that in 1997?
Your answer should be compact. 1.05. What is the ratio of the CO2 emissions (% of total fuel combustion) in Cote d'Ivoire in 1995 to that in 1997?
Give a very brief answer. 1.22. What is the ratio of the CO2 emissions (% of total fuel combustion) of Czech Republic in 1995 to that in 1997?
Provide a succinct answer. 1.02. What is the ratio of the CO2 emissions (% of total fuel combustion) of Iraq in 1995 to that in 1997?
Give a very brief answer. 1.54. What is the ratio of the CO2 emissions (% of total fuel combustion) in Arab World in 1995 to that in 1998?
Offer a terse response. 1.07. What is the ratio of the CO2 emissions (% of total fuel combustion) of Cote d'Ivoire in 1995 to that in 1998?
Provide a short and direct response. 1.21. What is the ratio of the CO2 emissions (% of total fuel combustion) of Czech Republic in 1995 to that in 1998?
Offer a very short reply. 1.06. What is the ratio of the CO2 emissions (% of total fuel combustion) in Iraq in 1995 to that in 1998?
Ensure brevity in your answer.  1.02. What is the ratio of the CO2 emissions (% of total fuel combustion) in Arab World in 1995 to that in 1999?
Keep it short and to the point. 1.08. What is the ratio of the CO2 emissions (% of total fuel combustion) in Cote d'Ivoire in 1995 to that in 1999?
Ensure brevity in your answer.  1.49. What is the ratio of the CO2 emissions (% of total fuel combustion) of Czech Republic in 1995 to that in 1999?
Give a very brief answer. 1.07. What is the ratio of the CO2 emissions (% of total fuel combustion) in Iraq in 1995 to that in 1999?
Offer a terse response. 0.78. What is the ratio of the CO2 emissions (% of total fuel combustion) in Arab World in 1995 to that in 2000?
Keep it short and to the point. 1.07. What is the ratio of the CO2 emissions (% of total fuel combustion) of Cote d'Ivoire in 1995 to that in 2000?
Provide a short and direct response. 1.38. What is the ratio of the CO2 emissions (% of total fuel combustion) in Czech Republic in 1995 to that in 2000?
Your response must be concise. 1.16. What is the ratio of the CO2 emissions (% of total fuel combustion) of Iraq in 1995 to that in 2000?
Your response must be concise. 0.8. What is the ratio of the CO2 emissions (% of total fuel combustion) in Arab World in 1995 to that in 2001?
Your answer should be very brief. 1.08. What is the ratio of the CO2 emissions (% of total fuel combustion) of Cote d'Ivoire in 1995 to that in 2001?
Provide a succinct answer. 1.47. What is the ratio of the CO2 emissions (% of total fuel combustion) of Czech Republic in 1995 to that in 2001?
Offer a terse response. 1.06. What is the ratio of the CO2 emissions (% of total fuel combustion) in Iraq in 1995 to that in 2001?
Give a very brief answer. 0.81. What is the ratio of the CO2 emissions (% of total fuel combustion) of Arab World in 1996 to that in 1997?
Offer a very short reply. 1.06. What is the ratio of the CO2 emissions (% of total fuel combustion) of Cote d'Ivoire in 1996 to that in 1997?
Your response must be concise. 1.18. What is the ratio of the CO2 emissions (% of total fuel combustion) in Czech Republic in 1996 to that in 1997?
Provide a short and direct response. 1.07. What is the ratio of the CO2 emissions (% of total fuel combustion) in Iraq in 1996 to that in 1997?
Offer a terse response. 1.65. What is the ratio of the CO2 emissions (% of total fuel combustion) of Arab World in 1996 to that in 1998?
Provide a succinct answer. 1.07. What is the ratio of the CO2 emissions (% of total fuel combustion) in Cote d'Ivoire in 1996 to that in 1998?
Make the answer very short. 1.17. What is the ratio of the CO2 emissions (% of total fuel combustion) in Czech Republic in 1996 to that in 1998?
Keep it short and to the point. 1.1. What is the ratio of the CO2 emissions (% of total fuel combustion) of Iraq in 1996 to that in 1998?
Give a very brief answer. 1.09. What is the ratio of the CO2 emissions (% of total fuel combustion) in Arab World in 1996 to that in 1999?
Keep it short and to the point. 1.08. What is the ratio of the CO2 emissions (% of total fuel combustion) of Cote d'Ivoire in 1996 to that in 1999?
Make the answer very short. 1.44. What is the ratio of the CO2 emissions (% of total fuel combustion) in Czech Republic in 1996 to that in 1999?
Give a very brief answer. 1.12. What is the ratio of the CO2 emissions (% of total fuel combustion) of Iraq in 1996 to that in 1999?
Provide a succinct answer. 0.84. What is the ratio of the CO2 emissions (% of total fuel combustion) of Arab World in 1996 to that in 2000?
Your response must be concise. 1.07. What is the ratio of the CO2 emissions (% of total fuel combustion) in Cote d'Ivoire in 1996 to that in 2000?
Provide a succinct answer. 1.33. What is the ratio of the CO2 emissions (% of total fuel combustion) of Czech Republic in 1996 to that in 2000?
Your answer should be compact. 1.22. What is the ratio of the CO2 emissions (% of total fuel combustion) in Iraq in 1996 to that in 2000?
Provide a short and direct response. 0.85. What is the ratio of the CO2 emissions (% of total fuel combustion) in Arab World in 1996 to that in 2001?
Provide a short and direct response. 1.09. What is the ratio of the CO2 emissions (% of total fuel combustion) of Cote d'Ivoire in 1996 to that in 2001?
Your answer should be compact. 1.42. What is the ratio of the CO2 emissions (% of total fuel combustion) of Czech Republic in 1996 to that in 2001?
Make the answer very short. 1.1. What is the ratio of the CO2 emissions (% of total fuel combustion) of Iraq in 1996 to that in 2001?
Your response must be concise. 0.87. What is the ratio of the CO2 emissions (% of total fuel combustion) of Arab World in 1997 to that in 1998?
Your response must be concise. 1.01. What is the ratio of the CO2 emissions (% of total fuel combustion) of Cote d'Ivoire in 1997 to that in 1998?
Provide a short and direct response. 0.99. What is the ratio of the CO2 emissions (% of total fuel combustion) in Czech Republic in 1997 to that in 1998?
Make the answer very short. 1.03. What is the ratio of the CO2 emissions (% of total fuel combustion) of Iraq in 1997 to that in 1998?
Your response must be concise. 0.66. What is the ratio of the CO2 emissions (% of total fuel combustion) of Arab World in 1997 to that in 1999?
Your answer should be compact. 1.02. What is the ratio of the CO2 emissions (% of total fuel combustion) in Cote d'Ivoire in 1997 to that in 1999?
Give a very brief answer. 1.21. What is the ratio of the CO2 emissions (% of total fuel combustion) in Czech Republic in 1997 to that in 1999?
Your answer should be very brief. 1.05. What is the ratio of the CO2 emissions (% of total fuel combustion) in Iraq in 1997 to that in 1999?
Your answer should be compact. 0.51. What is the ratio of the CO2 emissions (% of total fuel combustion) in Arab World in 1997 to that in 2000?
Offer a terse response. 1.01. What is the ratio of the CO2 emissions (% of total fuel combustion) in Cote d'Ivoire in 1997 to that in 2000?
Provide a succinct answer. 1.13. What is the ratio of the CO2 emissions (% of total fuel combustion) of Czech Republic in 1997 to that in 2000?
Provide a succinct answer. 1.14. What is the ratio of the CO2 emissions (% of total fuel combustion) of Iraq in 1997 to that in 2000?
Your answer should be very brief. 0.52. What is the ratio of the CO2 emissions (% of total fuel combustion) of Arab World in 1997 to that in 2001?
Ensure brevity in your answer.  1.03. What is the ratio of the CO2 emissions (% of total fuel combustion) of Cote d'Ivoire in 1997 to that in 2001?
Your answer should be very brief. 1.2. What is the ratio of the CO2 emissions (% of total fuel combustion) of Czech Republic in 1997 to that in 2001?
Give a very brief answer. 1.03. What is the ratio of the CO2 emissions (% of total fuel combustion) of Iraq in 1997 to that in 2001?
Provide a succinct answer. 0.53. What is the ratio of the CO2 emissions (% of total fuel combustion) in Arab World in 1998 to that in 1999?
Make the answer very short. 1.01. What is the ratio of the CO2 emissions (% of total fuel combustion) in Cote d'Ivoire in 1998 to that in 1999?
Your answer should be compact. 1.23. What is the ratio of the CO2 emissions (% of total fuel combustion) in Czech Republic in 1998 to that in 1999?
Your response must be concise. 1.02. What is the ratio of the CO2 emissions (% of total fuel combustion) of Iraq in 1998 to that in 1999?
Your answer should be compact. 0.77. What is the ratio of the CO2 emissions (% of total fuel combustion) in Arab World in 1998 to that in 2000?
Ensure brevity in your answer.  1. What is the ratio of the CO2 emissions (% of total fuel combustion) of Cote d'Ivoire in 1998 to that in 2000?
Your response must be concise. 1.14. What is the ratio of the CO2 emissions (% of total fuel combustion) in Czech Republic in 1998 to that in 2000?
Offer a very short reply. 1.1. What is the ratio of the CO2 emissions (% of total fuel combustion) of Iraq in 1998 to that in 2000?
Your answer should be very brief. 0.78. What is the ratio of the CO2 emissions (% of total fuel combustion) in Arab World in 1998 to that in 2001?
Keep it short and to the point. 1.01. What is the ratio of the CO2 emissions (% of total fuel combustion) in Cote d'Ivoire in 1998 to that in 2001?
Offer a terse response. 1.22. What is the ratio of the CO2 emissions (% of total fuel combustion) in Czech Republic in 1998 to that in 2001?
Your response must be concise. 1. What is the ratio of the CO2 emissions (% of total fuel combustion) of Iraq in 1998 to that in 2001?
Offer a terse response. 0.79. What is the ratio of the CO2 emissions (% of total fuel combustion) of Arab World in 1999 to that in 2000?
Ensure brevity in your answer.  0.99. What is the ratio of the CO2 emissions (% of total fuel combustion) in Cote d'Ivoire in 1999 to that in 2000?
Provide a succinct answer. 0.93. What is the ratio of the CO2 emissions (% of total fuel combustion) in Czech Republic in 1999 to that in 2000?
Ensure brevity in your answer.  1.09. What is the ratio of the CO2 emissions (% of total fuel combustion) of Iraq in 1999 to that in 2000?
Offer a terse response. 1.02. What is the ratio of the CO2 emissions (% of total fuel combustion) in Arab World in 1999 to that in 2001?
Ensure brevity in your answer.  1. What is the ratio of the CO2 emissions (% of total fuel combustion) of Cote d'Ivoire in 1999 to that in 2001?
Provide a short and direct response. 0.99. What is the ratio of the CO2 emissions (% of total fuel combustion) in Czech Republic in 1999 to that in 2001?
Offer a very short reply. 0.99. What is the ratio of the CO2 emissions (% of total fuel combustion) of Iraq in 1999 to that in 2001?
Provide a short and direct response. 1.03. What is the ratio of the CO2 emissions (% of total fuel combustion) of Arab World in 2000 to that in 2001?
Your answer should be very brief. 1.01. What is the ratio of the CO2 emissions (% of total fuel combustion) in Cote d'Ivoire in 2000 to that in 2001?
Provide a short and direct response. 1.06. What is the ratio of the CO2 emissions (% of total fuel combustion) in Czech Republic in 2000 to that in 2001?
Provide a succinct answer. 0.91. What is the ratio of the CO2 emissions (% of total fuel combustion) of Iraq in 2000 to that in 2001?
Your response must be concise. 1.01. What is the difference between the highest and the second highest CO2 emissions (% of total fuel combustion) of Arab World?
Offer a very short reply. 0.03. What is the difference between the highest and the second highest CO2 emissions (% of total fuel combustion) in Cote d'Ivoire?
Offer a terse response. 0.03. What is the difference between the highest and the second highest CO2 emissions (% of total fuel combustion) in Czech Republic?
Make the answer very short. 0.53. What is the difference between the highest and the second highest CO2 emissions (% of total fuel combustion) in Iraq?
Give a very brief answer. 0.2. What is the difference between the highest and the lowest CO2 emissions (% of total fuel combustion) in Arab World?
Provide a succinct answer. 0.52. What is the difference between the highest and the lowest CO2 emissions (% of total fuel combustion) of Cote d'Ivoire?
Make the answer very short. 4.02. What is the difference between the highest and the lowest CO2 emissions (% of total fuel combustion) of Czech Republic?
Your answer should be compact. 2.19. What is the difference between the highest and the lowest CO2 emissions (% of total fuel combustion) of Iraq?
Offer a terse response. 6.12. 